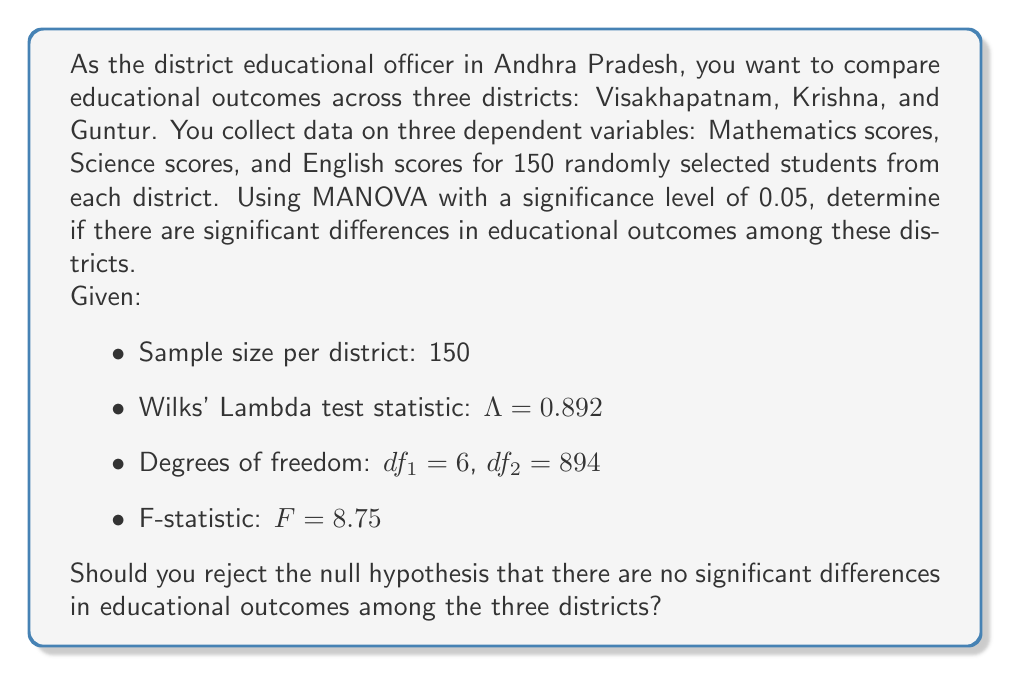Help me with this question. To solve this problem using MANOVA, we need to follow these steps:

1. State the null and alternative hypotheses:
   $H_0$: There are no significant differences in educational outcomes among the three districts.
   $H_a$: There are significant differences in educational outcomes among the three districts.

2. Identify the test statistic and its distribution:
   We are given Wilks' Lambda ($\Lambda$) as the test statistic. For MANOVA, Wilks' Lambda can be approximated by the F-distribution.

3. Calculate the critical F-value:
   Using the F-distribution with $df_1 = 6$ and $df_2 = 894$ at $\alpha = 0.05$, we can find the critical F-value. However, we are already given the calculated F-statistic, so we don't need to compute this.

4. Compare the calculated F-statistic to the critical F-value:
   The calculated F-statistic is $F = 8.75$. We need to compare this to the critical F-value from the F-distribution with $df_1 = 6$, $df_2 = 894$, and $\alpha = 0.05$.

   Using an F-table or statistical software, we find that the critical F-value is approximately 2.10.

5. Make a decision:
   Since the calculated F-statistic (8.75) is greater than the critical F-value (2.10), we reject the null hypothesis.

6. Interpret the results:
   Rejecting the null hypothesis means that there is sufficient evidence to conclude that there are significant differences in educational outcomes among the three districts (Visakhapatnam, Krishna, and Guntur) at the 0.05 significance level.

Note: The Wilks' Lambda value of 0.892 indicates that about 10.8% of the variance in the combination of Mathematics, Science, and English scores can be explained by the differences among the districts.
Answer: Yes, we should reject the null hypothesis. There is sufficient evidence to conclude that there are significant differences in educational outcomes among the three districts (Visakhapatnam, Krishna, and Guntur) at the 0.05 significance level. 